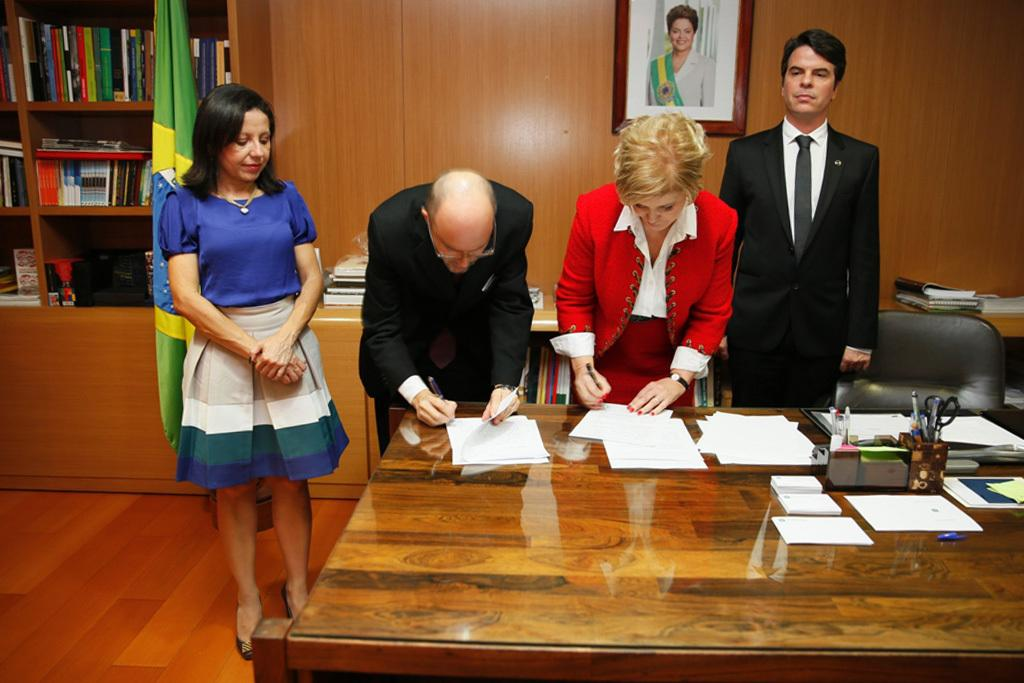What objects can be seen in the image related to reading or learning? There are books and papers on the table in the image. What other items can be seen in the image besides books and papers? There is a flag, a photo frame, and a table in the image. Are there any people present in the image? Yes, there are people standing in the image. What might the people be using the table for? The people might be using the table to hold the books, papers, and other items. What type of steel is used to construct the box in the image? There is no box present in the image, so the type of steel used for its construction cannot be determined. 